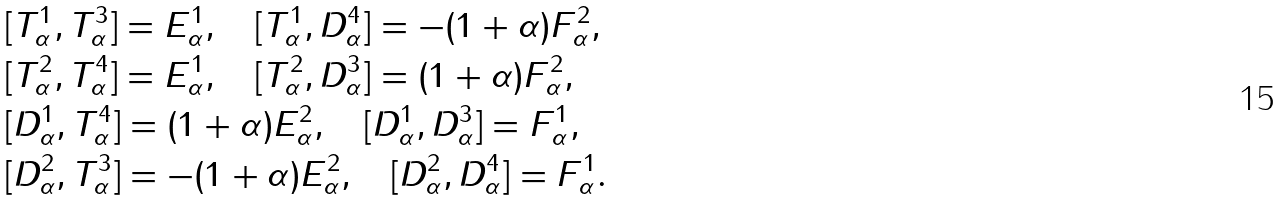<formula> <loc_0><loc_0><loc_500><loc_500>& [ T _ { \alpha } ^ { 1 } , T _ { \alpha } ^ { 3 } ] = E _ { \alpha } ^ { 1 } , \quad [ T _ { \alpha } ^ { 1 } , D _ { \alpha } ^ { 4 } ] = - ( 1 + \alpha ) F _ { \alpha } ^ { 2 } , \\ & [ T _ { \alpha } ^ { 2 } , T _ { \alpha } ^ { 4 } ] = E _ { \alpha } ^ { 1 } , \quad [ T _ { \alpha } ^ { 2 } , D _ { \alpha } ^ { 3 } ] = ( 1 + \alpha ) F _ { \alpha } ^ { 2 } , \\ & [ D _ { \alpha } ^ { 1 } , T _ { \alpha } ^ { 4 } ] = ( 1 + \alpha ) E _ { \alpha } ^ { 2 } , \quad [ D _ { \alpha } ^ { 1 } , D _ { \alpha } ^ { 3 } ] = F _ { \alpha } ^ { 1 } , \\ & [ D _ { \alpha } ^ { 2 } , T _ { \alpha } ^ { 3 } ] = - ( 1 + \alpha ) E _ { \alpha } ^ { 2 } , \quad [ D _ { \alpha } ^ { 2 } , D _ { \alpha } ^ { 4 } ] = F _ { \alpha } ^ { 1 } .</formula> 